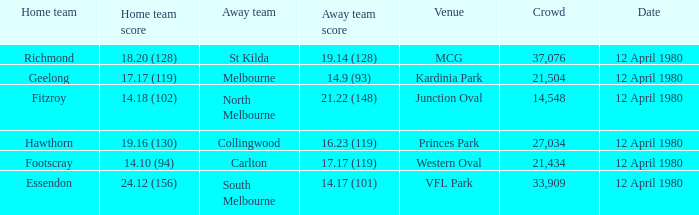Who was North Melbourne's home opponent? Fitzroy. 